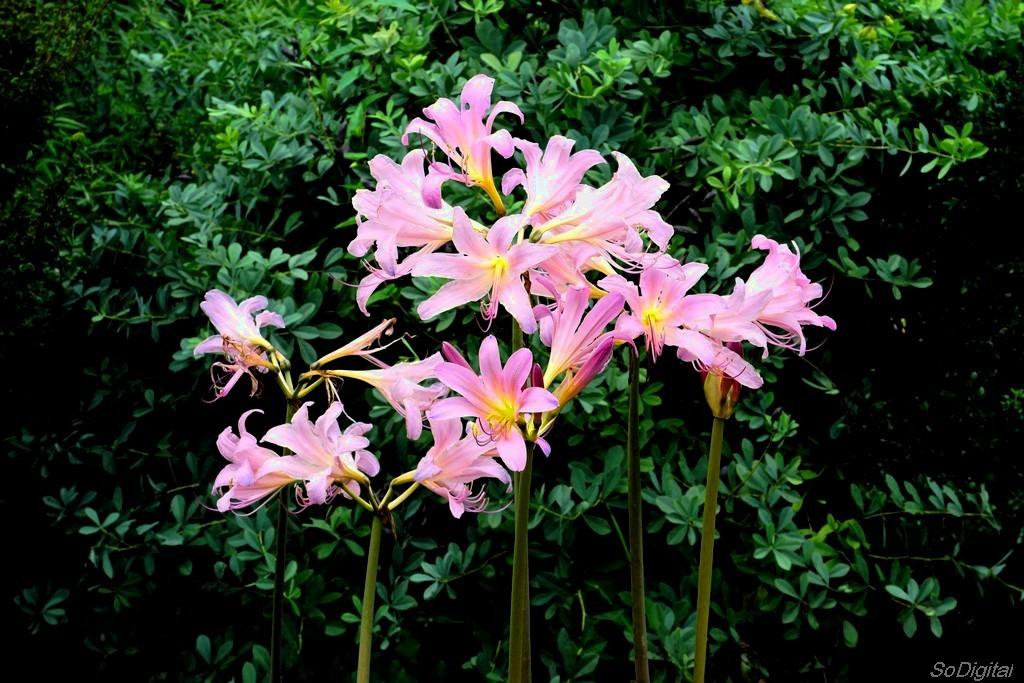What type of plant parts are visible in the image? There are leaves of a plant and flowers on the stems in the image. Where is the text located in the image? The text is in the bottom right corner of the image. What time does the clock show in the image? There is no clock present in the image. What type of grass is growing around the flowers in the image? There is no grass visible in the image; only leaves and flowers are present. 